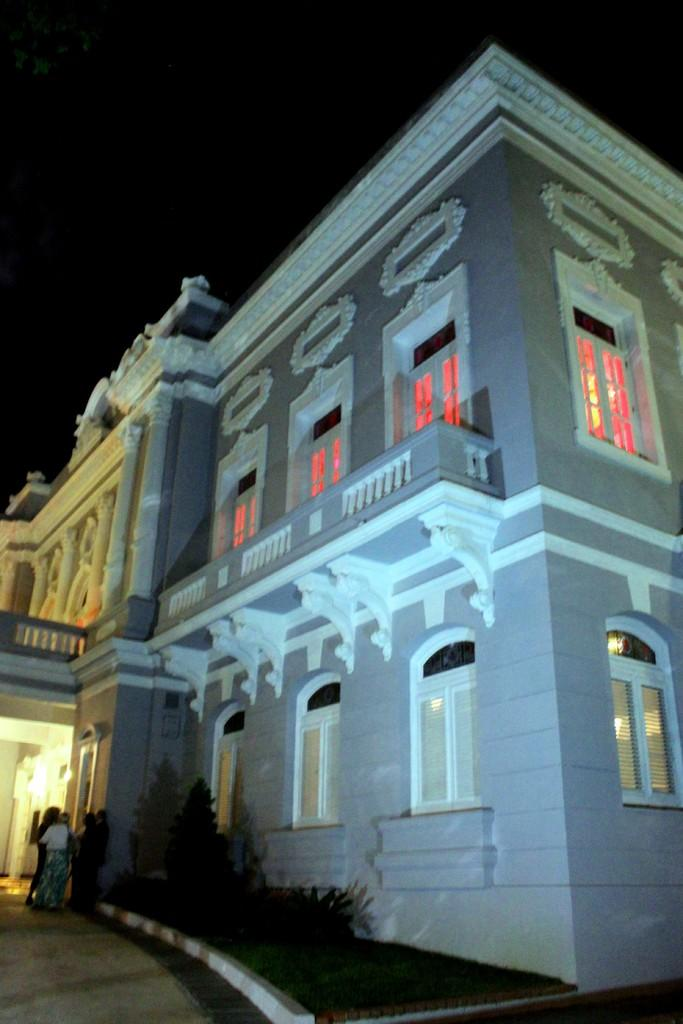What can be seen in the foreground area of the image? There are people, plants, and a building in the foreground area of the image. Can you describe the people in the image? The facts provided do not give specific details about the people, so we cannot describe them further. What type of plants are present in the foreground area of the image? The facts provided do not specify the type of plants, so we cannot describe them further. How does the building in the image react to the feeling of the people? The building in the image does not have feelings, as it is an inanimate object. Can you tell me how many times the people in the image coughed? The facts provided do not mention any coughing, so we cannot determine how many times the people coughed. 